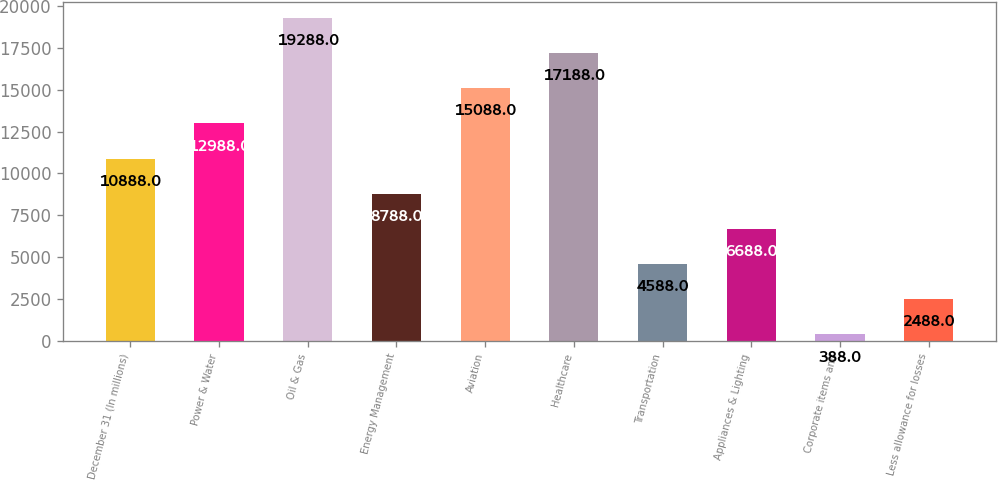Convert chart to OTSL. <chart><loc_0><loc_0><loc_500><loc_500><bar_chart><fcel>December 31 (In millions)<fcel>Power & Water<fcel>Oil & Gas<fcel>Energy Management<fcel>Aviation<fcel>Healthcare<fcel>Transportation<fcel>Appliances & Lighting<fcel>Corporate items and<fcel>Less allowance for losses<nl><fcel>10888<fcel>12988<fcel>19288<fcel>8788<fcel>15088<fcel>17188<fcel>4588<fcel>6688<fcel>388<fcel>2488<nl></chart> 